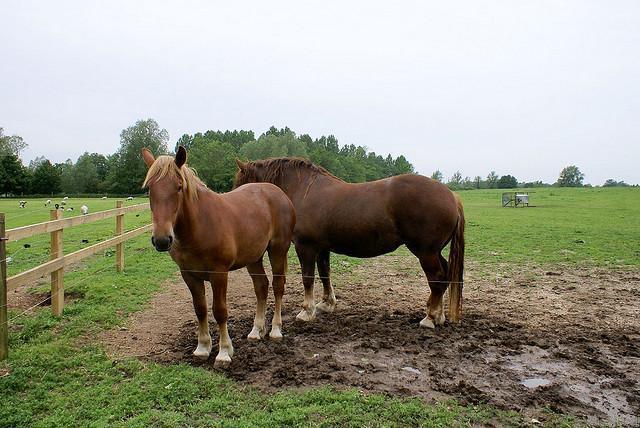How many horses in the fence?
Give a very brief answer. 2. How many animals?
Give a very brief answer. 2. How many horses can you see?
Give a very brief answer. 2. 